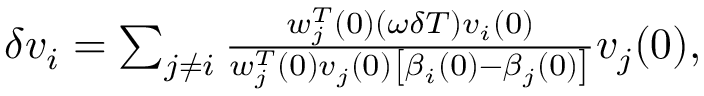Convert formula to latex. <formula><loc_0><loc_0><loc_500><loc_500>\begin{array} { r } { \delta v _ { i } = \sum _ { j \neq i } \frac { w _ { j } ^ { T } ( 0 ) ( \omega \delta T ) v _ { i } ( 0 ) } { w _ { j } ^ { T } ( 0 ) v _ { j } ( 0 ) \left [ \beta _ { i } ( 0 ) - \beta _ { j } ( 0 ) \right ] } v _ { j } ( 0 ) , } \end{array}</formula> 